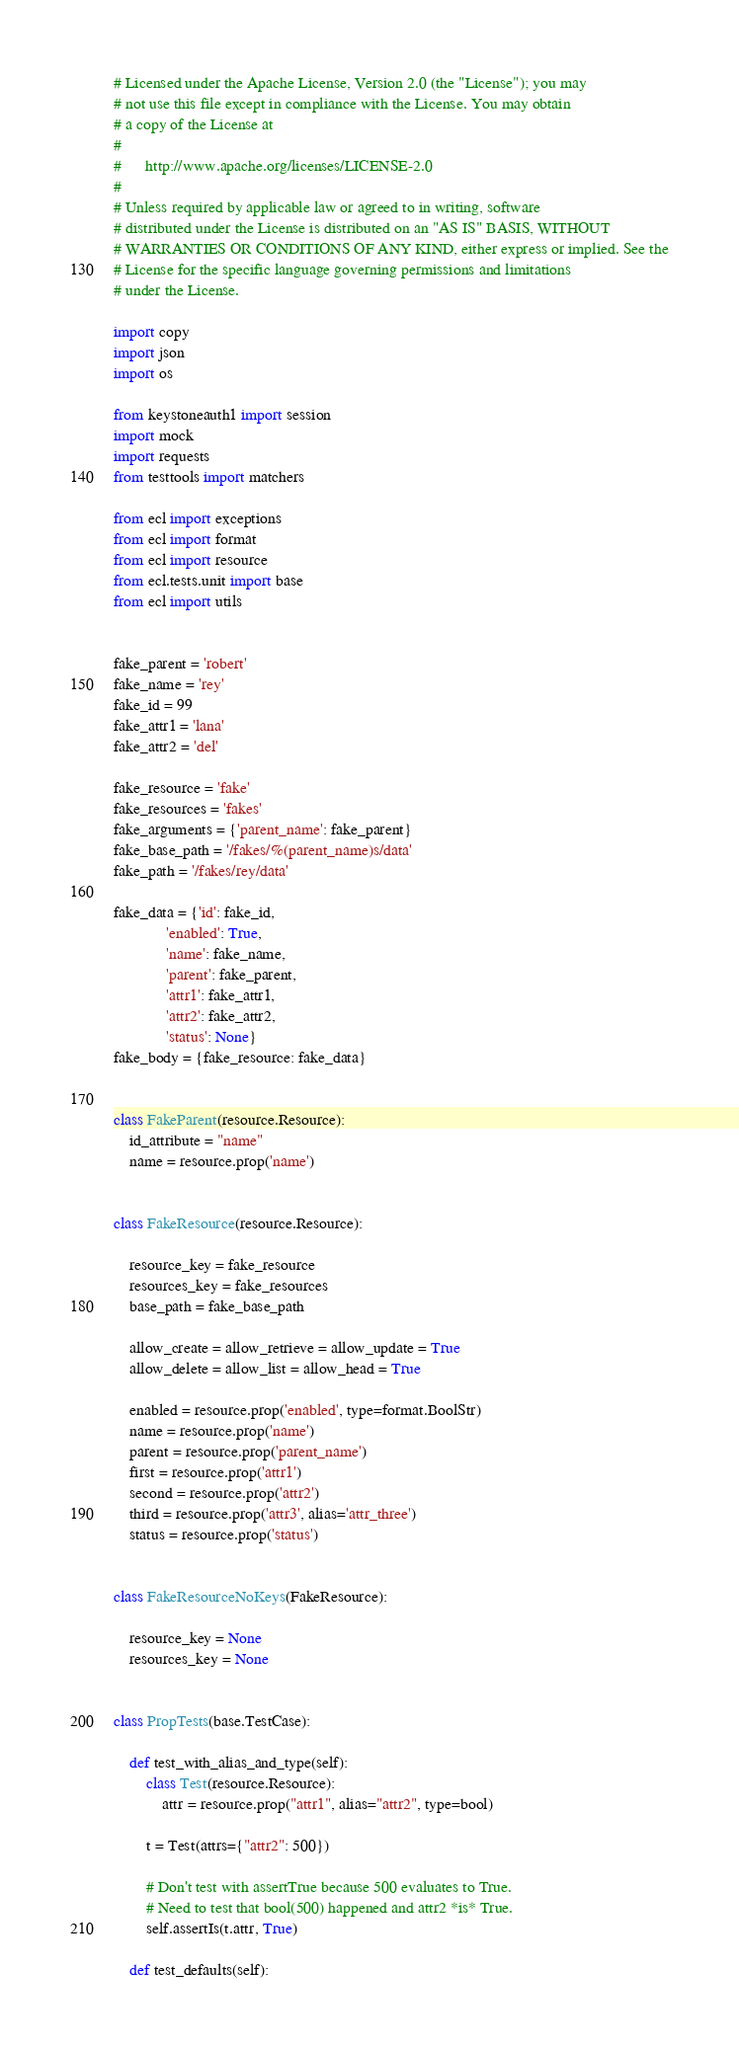<code> <loc_0><loc_0><loc_500><loc_500><_Python_># Licensed under the Apache License, Version 2.0 (the "License"); you may
# not use this file except in compliance with the License. You may obtain
# a copy of the License at
#
#      http://www.apache.org/licenses/LICENSE-2.0
#
# Unless required by applicable law or agreed to in writing, software
# distributed under the License is distributed on an "AS IS" BASIS, WITHOUT
# WARRANTIES OR CONDITIONS OF ANY KIND, either express or implied. See the
# License for the specific language governing permissions and limitations
# under the License.

import copy
import json
import os

from keystoneauth1 import session
import mock
import requests
from testtools import matchers

from ecl import exceptions
from ecl import format
from ecl import resource
from ecl.tests.unit import base
from ecl import utils


fake_parent = 'robert'
fake_name = 'rey'
fake_id = 99
fake_attr1 = 'lana'
fake_attr2 = 'del'

fake_resource = 'fake'
fake_resources = 'fakes'
fake_arguments = {'parent_name': fake_parent}
fake_base_path = '/fakes/%(parent_name)s/data'
fake_path = '/fakes/rey/data'

fake_data = {'id': fake_id,
             'enabled': True,
             'name': fake_name,
             'parent': fake_parent,
             'attr1': fake_attr1,
             'attr2': fake_attr2,
             'status': None}
fake_body = {fake_resource: fake_data}


class FakeParent(resource.Resource):
    id_attribute = "name"
    name = resource.prop('name')


class FakeResource(resource.Resource):

    resource_key = fake_resource
    resources_key = fake_resources
    base_path = fake_base_path

    allow_create = allow_retrieve = allow_update = True
    allow_delete = allow_list = allow_head = True

    enabled = resource.prop('enabled', type=format.BoolStr)
    name = resource.prop('name')
    parent = resource.prop('parent_name')
    first = resource.prop('attr1')
    second = resource.prop('attr2')
    third = resource.prop('attr3', alias='attr_three')
    status = resource.prop('status')


class FakeResourceNoKeys(FakeResource):

    resource_key = None
    resources_key = None


class PropTests(base.TestCase):

    def test_with_alias_and_type(self):
        class Test(resource.Resource):
            attr = resource.prop("attr1", alias="attr2", type=bool)

        t = Test(attrs={"attr2": 500})

        # Don't test with assertTrue because 500 evaluates to True.
        # Need to test that bool(500) happened and attr2 *is* True.
        self.assertIs(t.attr, True)

    def test_defaults(self):</code> 